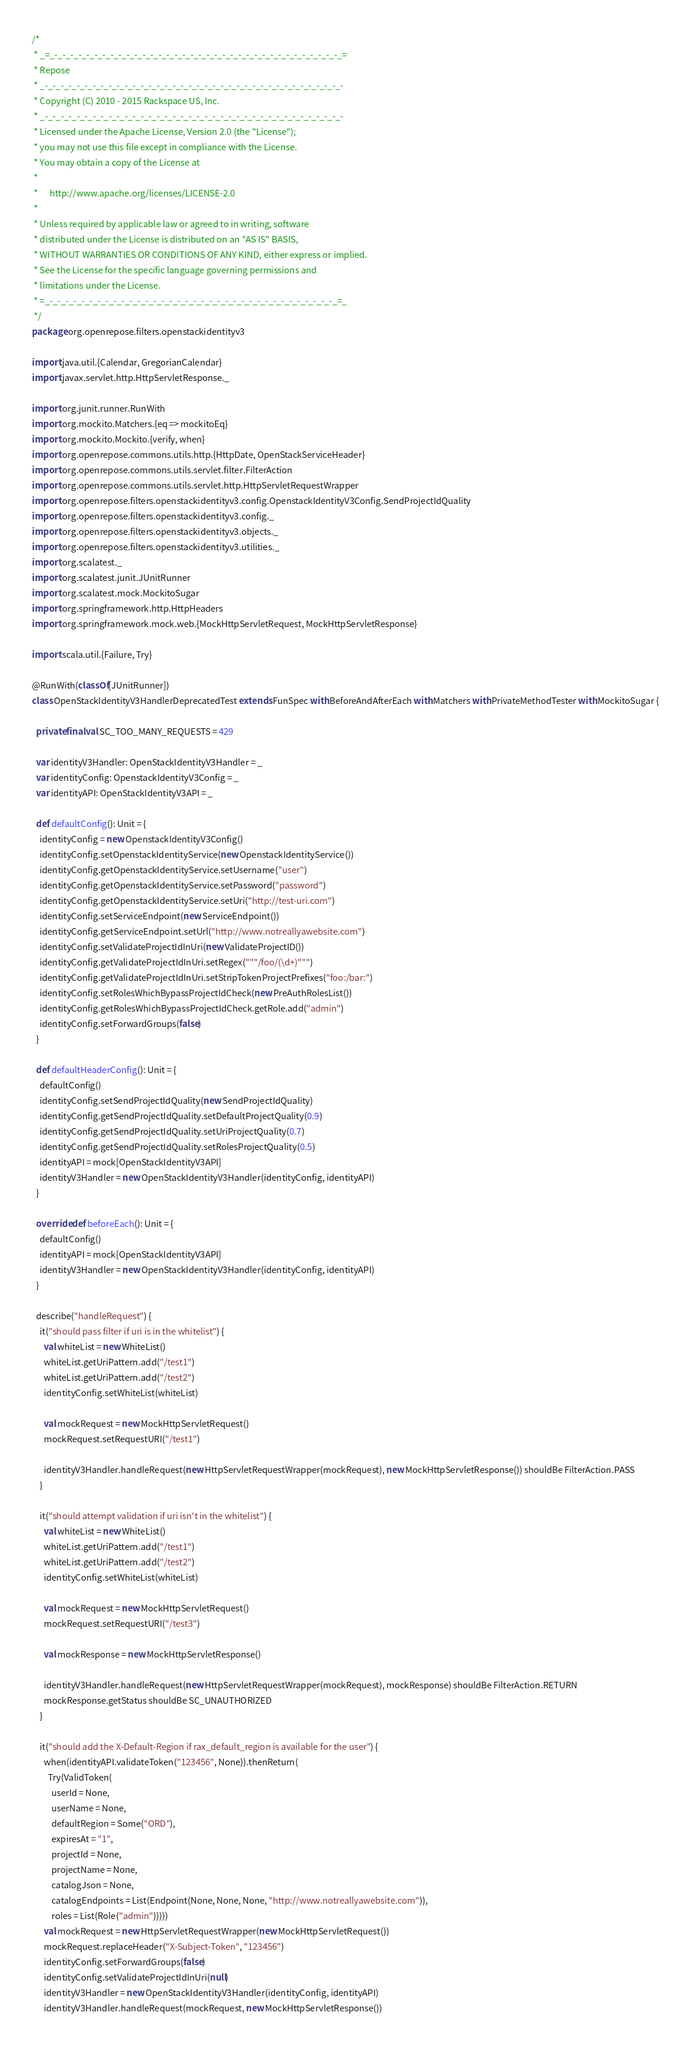<code> <loc_0><loc_0><loc_500><loc_500><_Scala_>/*
 * _=_-_-_-_-_-_-_-_-_-_-_-_-_-_-_-_-_-_-_-_-_-_-_-_-_-_-_-_-_-_-_-_-_-_-_-_-_=
 * Repose
 * _-_-_-_-_-_-_-_-_-_-_-_-_-_-_-_-_-_-_-_-_-_-_-_-_-_-_-_-_-_-_-_-_-_-_-_-_-_-
 * Copyright (C) 2010 - 2015 Rackspace US, Inc.
 * _-_-_-_-_-_-_-_-_-_-_-_-_-_-_-_-_-_-_-_-_-_-_-_-_-_-_-_-_-_-_-_-_-_-_-_-_-_-
 * Licensed under the Apache License, Version 2.0 (the "License");
 * you may not use this file except in compliance with the License.
 * You may obtain a copy of the License at
 * 
 *      http://www.apache.org/licenses/LICENSE-2.0
 * 
 * Unless required by applicable law or agreed to in writing, software
 * distributed under the License is distributed on an "AS IS" BASIS,
 * WITHOUT WARRANTIES OR CONDITIONS OF ANY KIND, either express or implied.
 * See the License for the specific language governing permissions and
 * limitations under the License.
 * =_-_-_-_-_-_-_-_-_-_-_-_-_-_-_-_-_-_-_-_-_-_-_-_-_-_-_-_-_-_-_-_-_-_-_-_-_=_
 */
package org.openrepose.filters.openstackidentityv3

import java.util.{Calendar, GregorianCalendar}
import javax.servlet.http.HttpServletResponse._

import org.junit.runner.RunWith
import org.mockito.Matchers.{eq => mockitoEq}
import org.mockito.Mockito.{verify, when}
import org.openrepose.commons.utils.http.{HttpDate, OpenStackServiceHeader}
import org.openrepose.commons.utils.servlet.filter.FilterAction
import org.openrepose.commons.utils.servlet.http.HttpServletRequestWrapper
import org.openrepose.filters.openstackidentityv3.config.OpenstackIdentityV3Config.SendProjectIdQuality
import org.openrepose.filters.openstackidentityv3.config._
import org.openrepose.filters.openstackidentityv3.objects._
import org.openrepose.filters.openstackidentityv3.utilities._
import org.scalatest._
import org.scalatest.junit.JUnitRunner
import org.scalatest.mock.MockitoSugar
import org.springframework.http.HttpHeaders
import org.springframework.mock.web.{MockHttpServletRequest, MockHttpServletResponse}

import scala.util.{Failure, Try}

@RunWith(classOf[JUnitRunner])
class OpenStackIdentityV3HandlerDeprecatedTest extends FunSpec with BeforeAndAfterEach with Matchers with PrivateMethodTester with MockitoSugar {

  private final val SC_TOO_MANY_REQUESTS = 429

  var identityV3Handler: OpenStackIdentityV3Handler = _
  var identityConfig: OpenstackIdentityV3Config = _
  var identityAPI: OpenStackIdentityV3API = _

  def defaultConfig(): Unit = {
    identityConfig = new OpenstackIdentityV3Config()
    identityConfig.setOpenstackIdentityService(new OpenstackIdentityService())
    identityConfig.getOpenstackIdentityService.setUsername("user")
    identityConfig.getOpenstackIdentityService.setPassword("password")
    identityConfig.getOpenstackIdentityService.setUri("http://test-uri.com")
    identityConfig.setServiceEndpoint(new ServiceEndpoint())
    identityConfig.getServiceEndpoint.setUrl("http://www.notreallyawebsite.com")
    identityConfig.setValidateProjectIdInUri(new ValidateProjectID())
    identityConfig.getValidateProjectIdInUri.setRegex("""/foo/(\d+)""")
    identityConfig.getValidateProjectIdInUri.setStripTokenProjectPrefixes("foo:/bar:")
    identityConfig.setRolesWhichBypassProjectIdCheck(new PreAuthRolesList())
    identityConfig.getRolesWhichBypassProjectIdCheck.getRole.add("admin")
    identityConfig.setForwardGroups(false)
  }

  def defaultHeaderConfig(): Unit = {
    defaultConfig()
    identityConfig.setSendProjectIdQuality(new SendProjectIdQuality)
    identityConfig.getSendProjectIdQuality.setDefaultProjectQuality(0.9)
    identityConfig.getSendProjectIdQuality.setUriProjectQuality(0.7)
    identityConfig.getSendProjectIdQuality.setRolesProjectQuality(0.5)
    identityAPI = mock[OpenStackIdentityV3API]
    identityV3Handler = new OpenStackIdentityV3Handler(identityConfig, identityAPI)
  }

  override def beforeEach(): Unit = {
    defaultConfig()
    identityAPI = mock[OpenStackIdentityV3API]
    identityV3Handler = new OpenStackIdentityV3Handler(identityConfig, identityAPI)
  }

  describe("handleRequest") {
    it("should pass filter if uri is in the whitelist") {
      val whiteList = new WhiteList()
      whiteList.getUriPattern.add("/test1")
      whiteList.getUriPattern.add("/test2")
      identityConfig.setWhiteList(whiteList)

      val mockRequest = new MockHttpServletRequest()
      mockRequest.setRequestURI("/test1")

      identityV3Handler.handleRequest(new HttpServletRequestWrapper(mockRequest), new MockHttpServletResponse()) shouldBe FilterAction.PASS
    }

    it("should attempt validation if uri isn't in the whitelist") {
      val whiteList = new WhiteList()
      whiteList.getUriPattern.add("/test1")
      whiteList.getUriPattern.add("/test2")
      identityConfig.setWhiteList(whiteList)

      val mockRequest = new MockHttpServletRequest()
      mockRequest.setRequestURI("/test3")

      val mockResponse = new MockHttpServletResponse()

      identityV3Handler.handleRequest(new HttpServletRequestWrapper(mockRequest), mockResponse) shouldBe FilterAction.RETURN
      mockResponse.getStatus shouldBe SC_UNAUTHORIZED
    }

    it("should add the X-Default-Region if rax_default_region is available for the user") {
      when(identityAPI.validateToken("123456", None)).thenReturn(
        Try(ValidToken(
          userId = None,
          userName = None,
          defaultRegion = Some("ORD"),
          expiresAt = "1",
          projectId = None,
          projectName = None,
          catalogJson = None,
          catalogEndpoints = List(Endpoint(None, None, None, "http://www.notreallyawebsite.com")),
          roles = List(Role("admin")))))
      val mockRequest = new HttpServletRequestWrapper(new MockHttpServletRequest())
      mockRequest.replaceHeader("X-Subject-Token", "123456")
      identityConfig.setForwardGroups(false)
      identityConfig.setValidateProjectIdInUri(null)
      identityV3Handler = new OpenStackIdentityV3Handler(identityConfig, identityAPI)
      identityV3Handler.handleRequest(mockRequest, new MockHttpServletResponse())</code> 